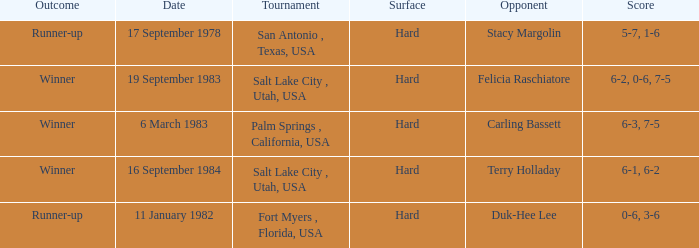Who was the opponent for the match were the outcome was runner-up and the score was 5-7, 1-6? Stacy Margolin. 